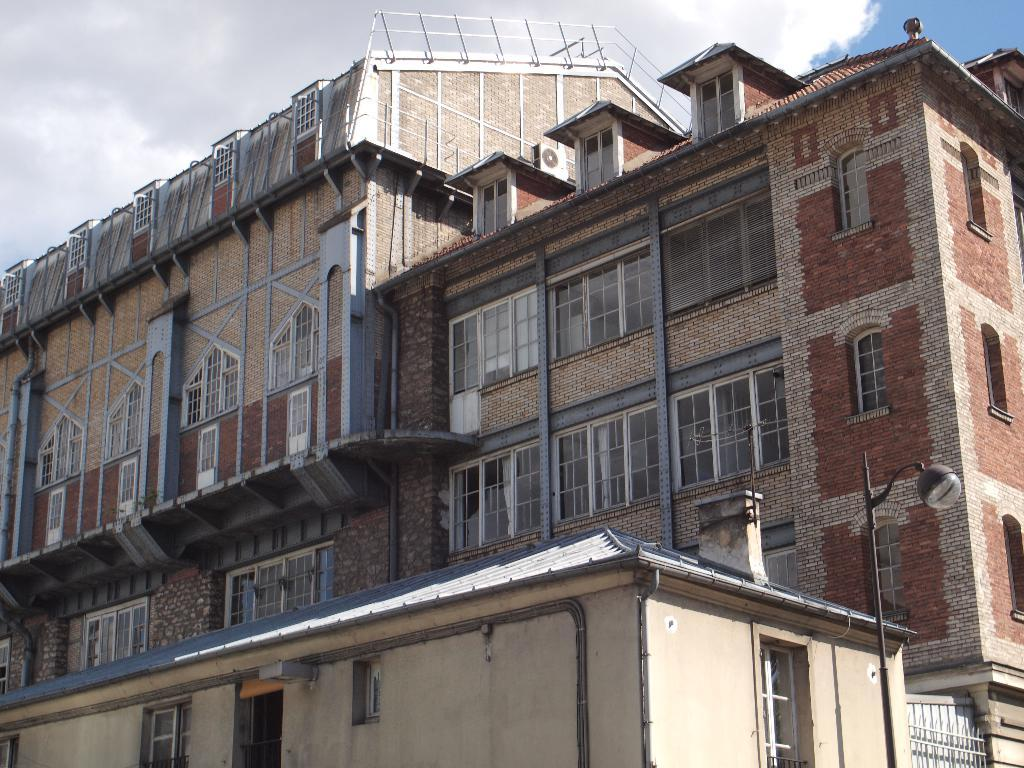What type of structure is in the image? There is a building in the image. What feature of the building is mentioned in the facts? The building has multiple windows. What else can be seen in the image besides the building? There is a pole in the image, and a light is present on the pole. What can be seen in the background of the image? There are clouds and the sky visible in the background of the image. What type of ball is being used to support the building in the image? There is no ball present in the image, and the building is not being supported by any ball. 